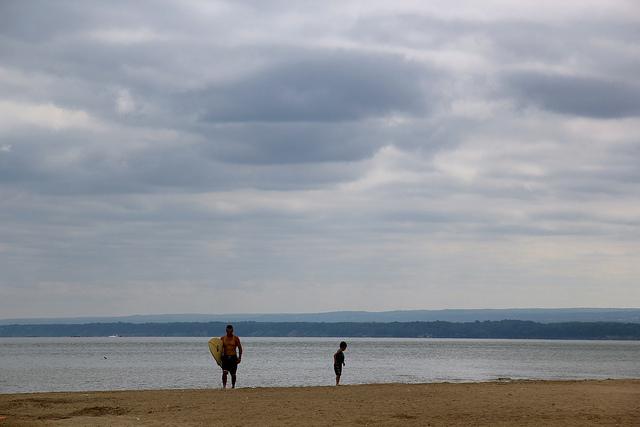What is the man doing?
Keep it brief. Surfing. What is the man carrying?
Quick response, please. Surfboard. Is there something on the horizon?
Short answer required. Yes. How many people are on the beach?
Write a very short answer. 2. Is it windy?
Be succinct. No. What is in the air?
Concise answer only. Clouds. How many people?
Answer briefly. 2. How many people are walking?
Be succinct. 2. Is this man coming out the water?
Give a very brief answer. Yes. Is the sun shining?
Give a very brief answer. No. What is the child looking at?
Write a very short answer. Water. How many surfboards are in this photo?
Write a very short answer. 1. Is there a glare?
Be succinct. No. Are there any people around?
Be succinct. Yes. What is between these two people?
Answer briefly. Sand. 